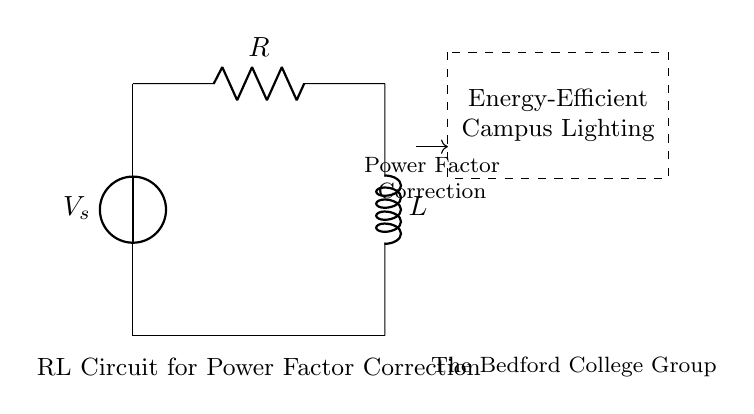What is the type of voltage source in the circuit? The circuit uses a voltage source, which is indicated by the symbol at the top left of the diagram. This source supplies electrical energy to the circuit.
Answer: Voltage source What components are present in the RL circuit? The RL circuit consists of a resistor and an inductor connected in series. The resistor is labeled R and the inductor is labeled L in the diagram.
Answer: Resistor and inductor What is the purpose of the dashed rectangle in the circuit? The dashed rectangle indicates a section representing 'Energy-Efficient Campus Lighting'. It shows that this RL circuit is part of a system designed for energy-efficient lighting.
Answer: Energy-Efficient Campus Lighting Why is power factor correction used in this RL circuit? Power factor correction is utilized in this circuit to improve the efficiency of the lighting system. In RL circuits, inductors can cause a lagging power factor, reducing the effectiveness of power usage.
Answer: Improve efficiency What does the connection from the resistor to the inductor signify? The connection from the resistor to the inductor shows that they are connected in series within the circuit. This means the same current passes through both components.
Answer: Series connection What is the potential impact of having a low power factor? A low power factor can result in increased energy costs and reduced efficiency in the lighting systems, leading to potential wastage of electrical resources.
Answer: Increased energy costs 